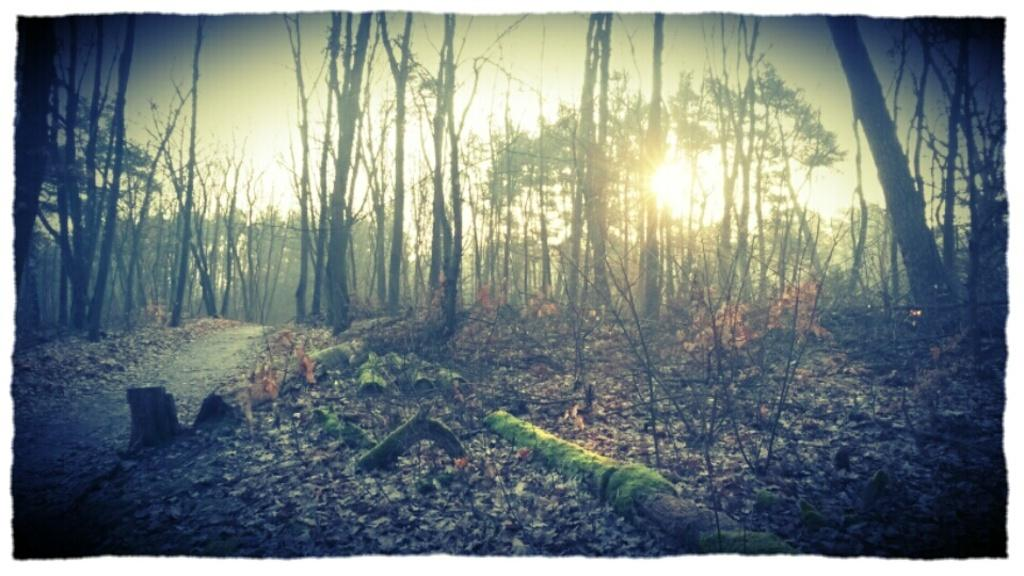What can be seen on the left side of the image? There is a path on the left side of the image. What is visible in the background of the image? There are many trees in the background of the image. What is present on the ground in the image? Dry leaves are present on the ground in the image. What is visible at the top of the image? The sun is visible at the top of the image. Can you see an airplane flying over the trees in the image? There is no airplane visible in the image; it only features a path, trees, dry leaves, and the sun. What type of sack is being carried by the person walking on the path in the image? There is no person or sack present in the image; it only features a path, trees, dry leaves, and the sun. 